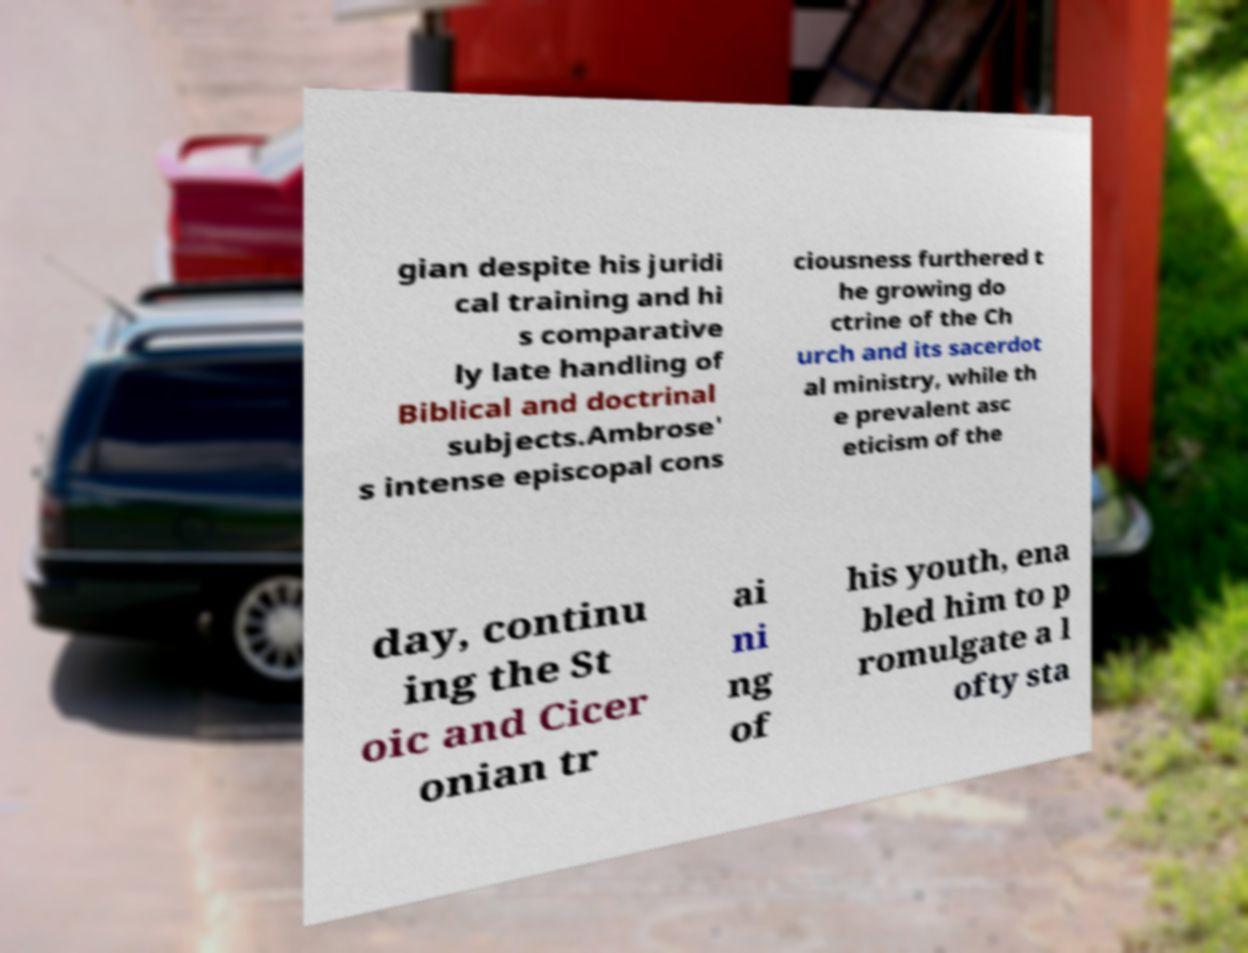Can you accurately transcribe the text from the provided image for me? gian despite his juridi cal training and hi s comparative ly late handling of Biblical and doctrinal subjects.Ambrose' s intense episcopal cons ciousness furthered t he growing do ctrine of the Ch urch and its sacerdot al ministry, while th e prevalent asc eticism of the day, continu ing the St oic and Cicer onian tr ai ni ng of his youth, ena bled him to p romulgate a l ofty sta 